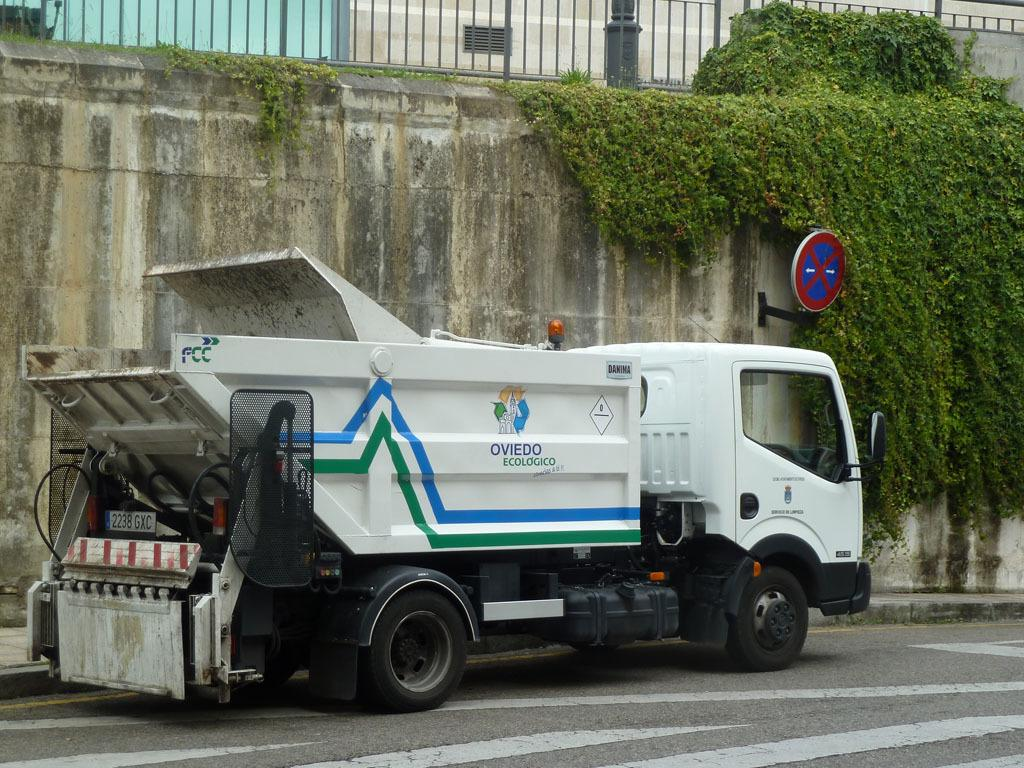What type of vehicle is on the road in the image? There is a truck on the road in the image. What kind of plants can be seen in the image? There are creeper plants in the image. What is on the wall in the image? There is a sign board on the wall in the image. What type of architectural feature is visible at the top of the image? There are iron grilles visible at the top of the image. What type of jelly can be seen in the harmony of the iron grilles in the image? There is no jelly present in the image, and the iron grilles are not associated with harmony. 